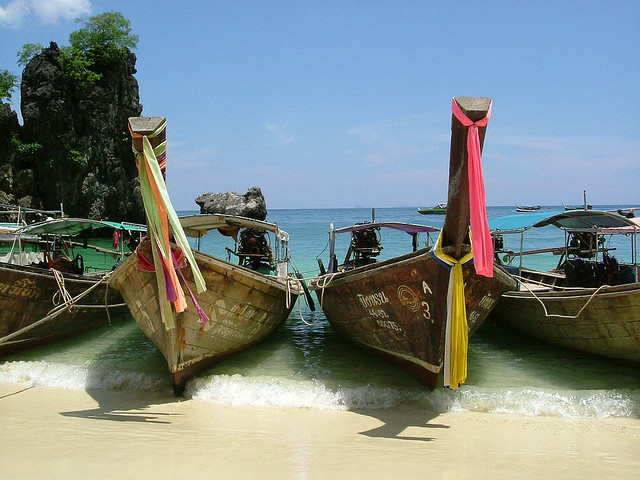Describe the objects in this image and their specific colors. I can see boat in darkgray, black, maroon, olive, and salmon tones, boat in darkgray, olive, black, and gray tones, boat in darkgray, black, lightblue, and darkgreen tones, boat in darkgray, black, gray, and darkgreen tones, and boat in darkgray, black, blue, olive, and teal tones in this image. 